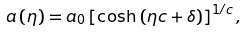<formula> <loc_0><loc_0><loc_500><loc_500>a \left ( \eta \right ) = a _ { 0 } \left [ \cosh \left ( \eta c + \delta \right ) \right ] ^ { 1 / c } ,</formula> 